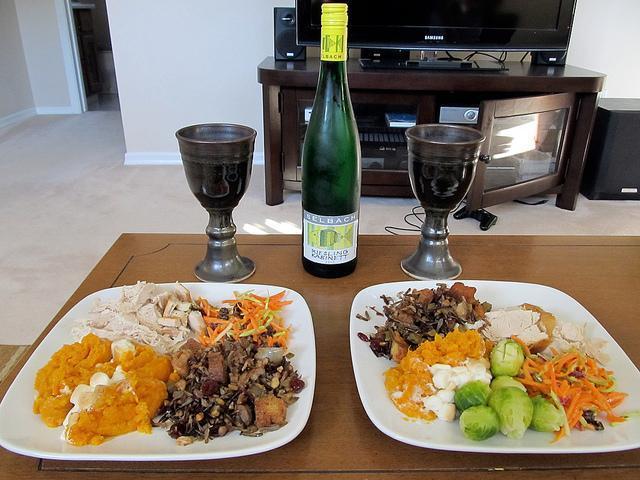How many cups can be seen?
Give a very brief answer. 2. How many tvs are visible?
Give a very brief answer. 2. How many wine glasses can be seen?
Give a very brief answer. 2. 